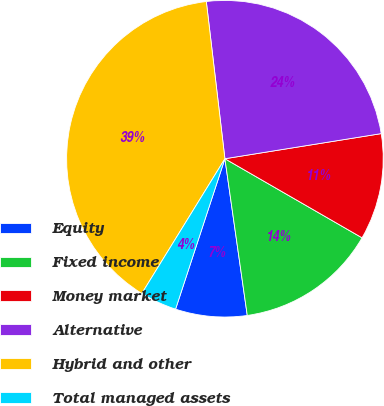Convert chart to OTSL. <chart><loc_0><loc_0><loc_500><loc_500><pie_chart><fcel>Equity<fcel>Fixed income<fcel>Money market<fcel>Alternative<fcel>Hybrid and other<fcel>Total managed assets<nl><fcel>7.3%<fcel>14.42%<fcel>10.86%<fcel>24.34%<fcel>39.33%<fcel>3.75%<nl></chart> 